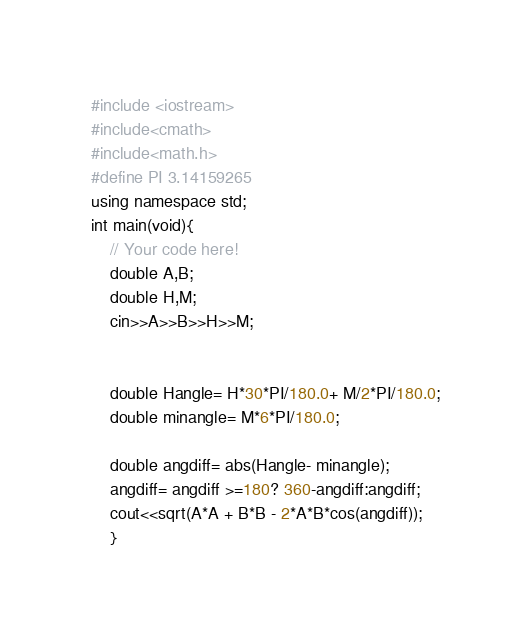<code> <loc_0><loc_0><loc_500><loc_500><_C++_>#include <iostream>
#include<cmath>
#include<math.h>
#define PI 3.14159265
using namespace std;
int main(void){
    // Your code here!
    double A,B;
    double H,M;
    cin>>A>>B>>H>>M;
    
   
    double Hangle= H*30*PI/180.0+ M/2*PI/180.0;
    double minangle= M*6*PI/180.0;
    
    double angdiff= abs(Hangle- minangle);
    angdiff= angdiff >=180? 360-angdiff:angdiff;
    cout<<sqrt(A*A + B*B - 2*A*B*cos(angdiff));
    }


</code> 